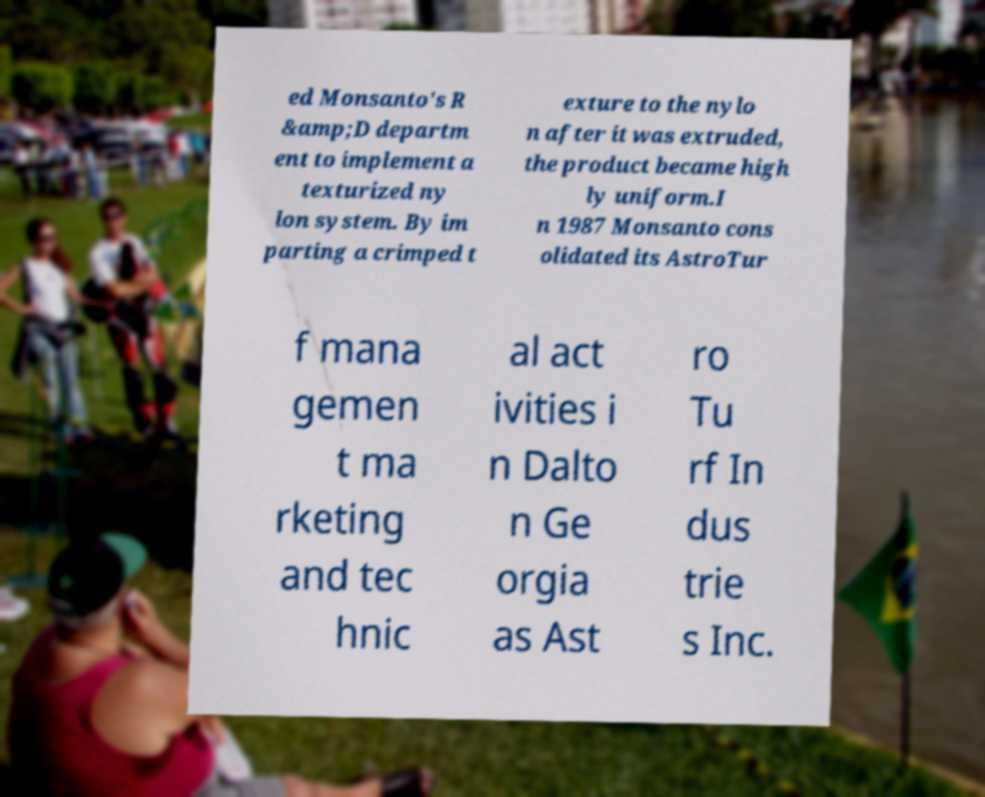What messages or text are displayed in this image? I need them in a readable, typed format. ed Monsanto's R &amp;D departm ent to implement a texturized ny lon system. By im parting a crimped t exture to the nylo n after it was extruded, the product became high ly uniform.I n 1987 Monsanto cons olidated its AstroTur f mana gemen t ma rketing and tec hnic al act ivities i n Dalto n Ge orgia as Ast ro Tu rf In dus trie s Inc. 